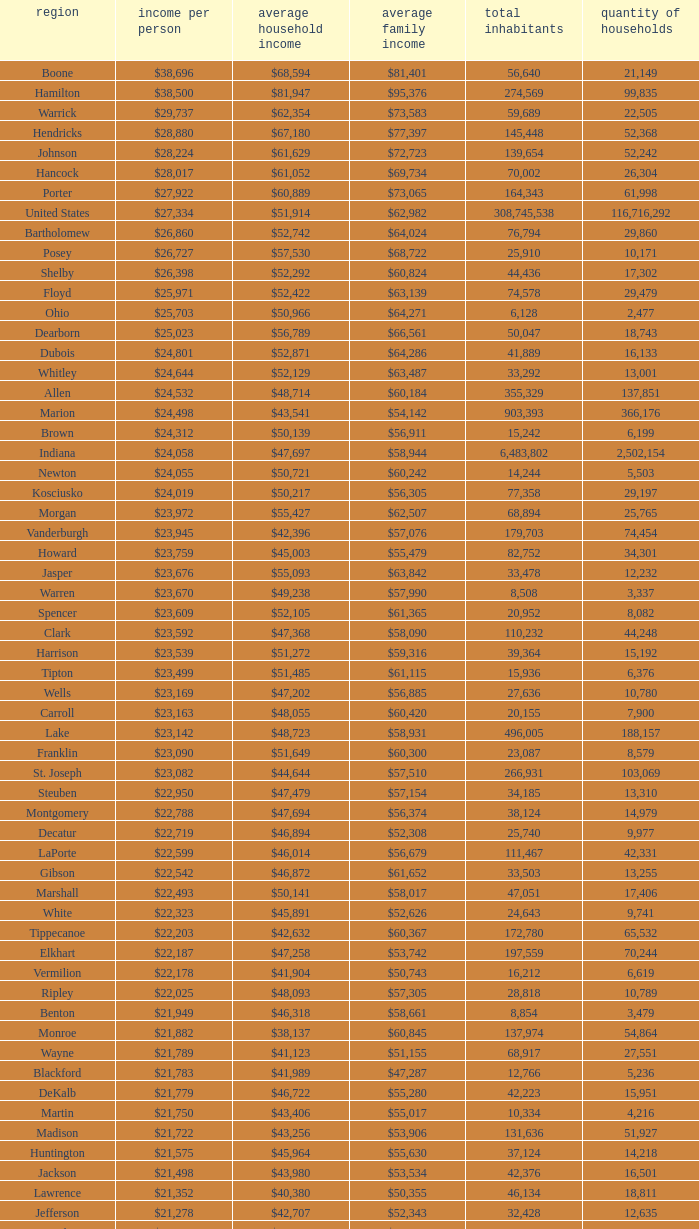What is the Median family income when the Median household income is $38,137? $60,845. 